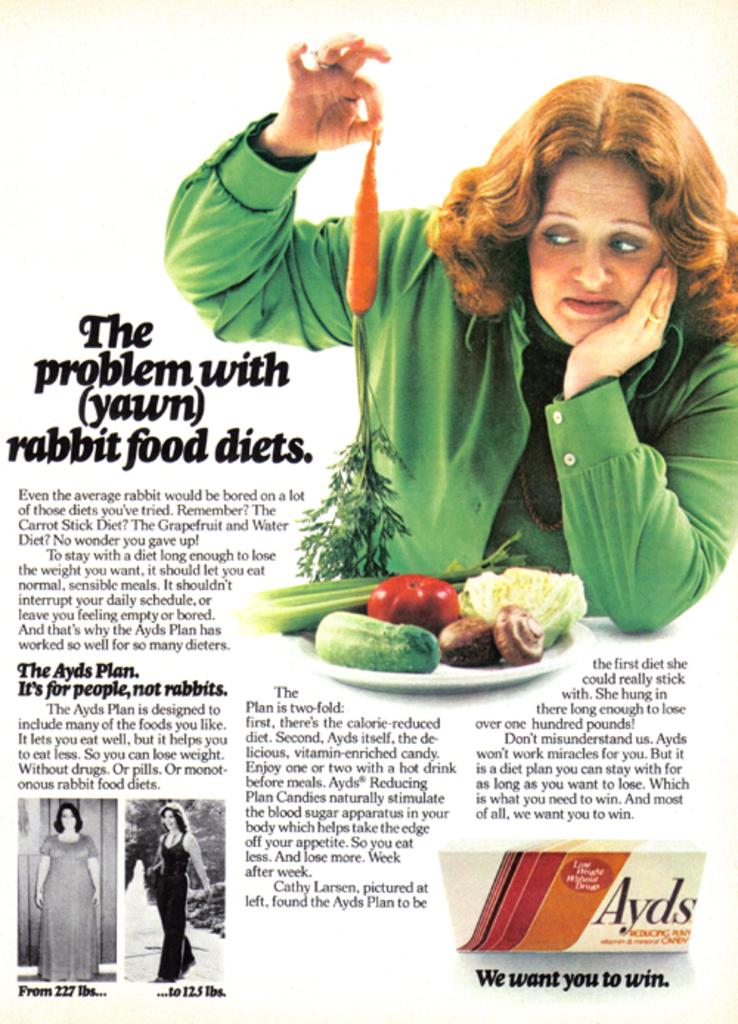What kind of diet is there a problem with?
Your answer should be compact. Rabbit food. What do they want people to win?
Provide a succinct answer. Ayds. 